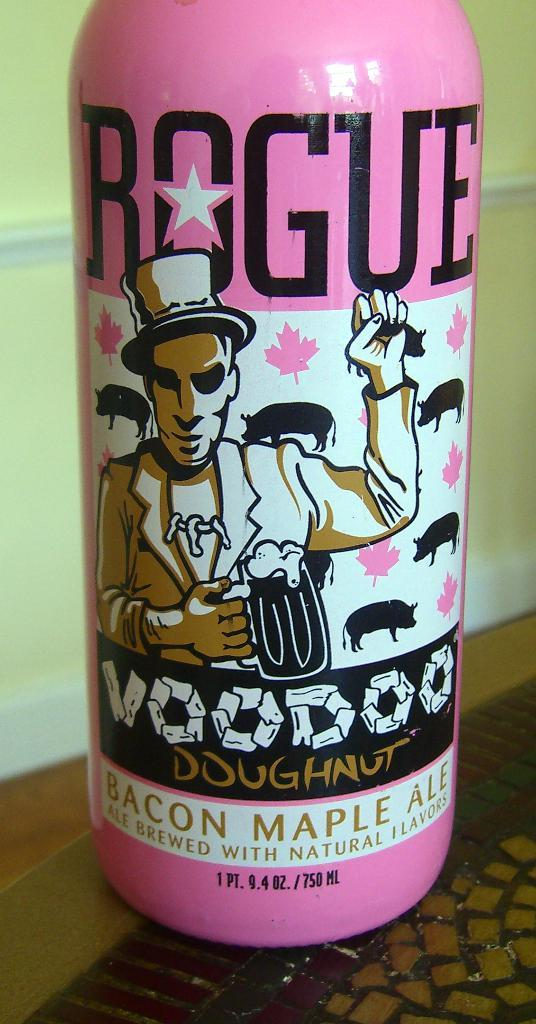What color is the bottle in the image? The bottle in the image is pink-colored. What can be found on the surface of the bottle? There is printing on the bottle. What type of peace symbol is depicted on the bottle? There is no peace symbol present on the bottle; it only has printing on its surface. How many yams are visible in the image? There are no yams present in the image. 